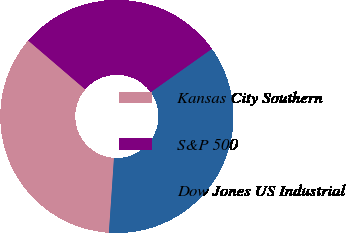Convert chart. <chart><loc_0><loc_0><loc_500><loc_500><pie_chart><fcel>Kansas City Southern<fcel>S&P 500<fcel>Dow Jones US Industrial<nl><fcel>35.19%<fcel>28.91%<fcel>35.9%<nl></chart> 